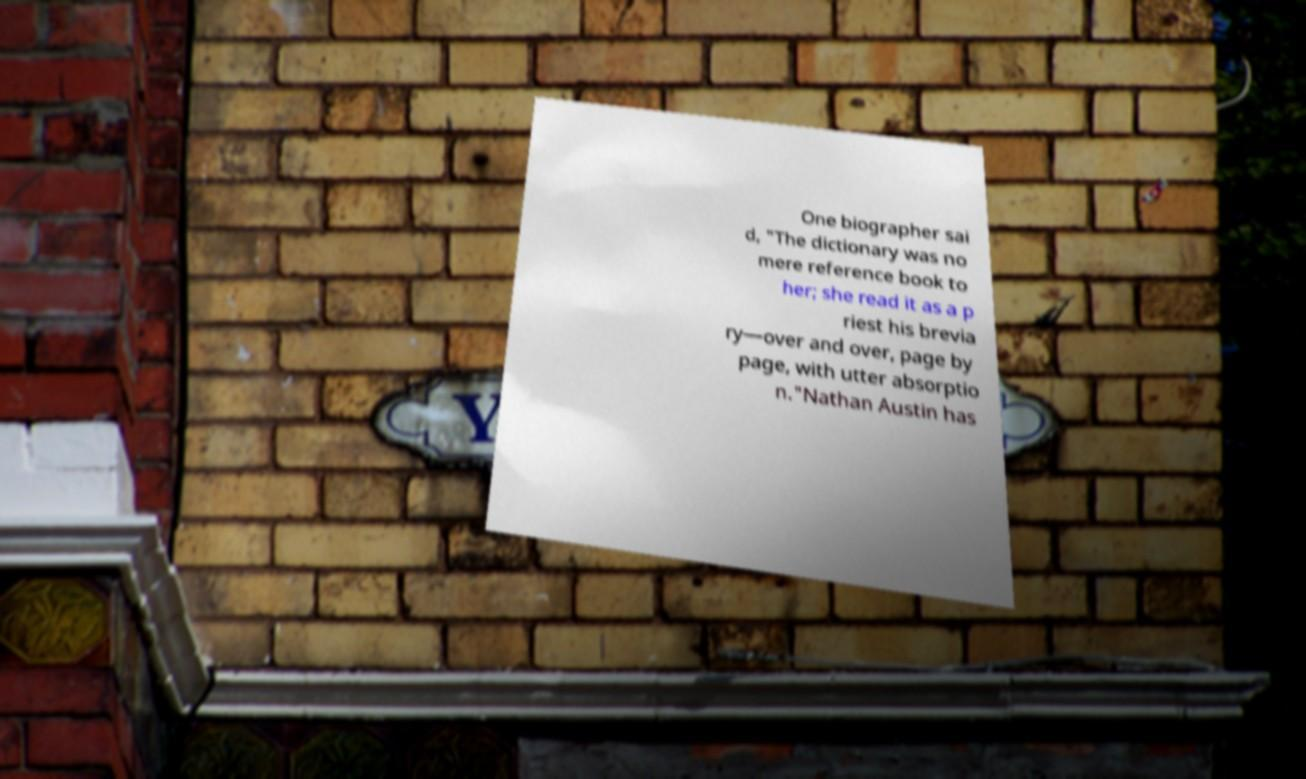There's text embedded in this image that I need extracted. Can you transcribe it verbatim? One biographer sai d, "The dictionary was no mere reference book to her; she read it as a p riest his brevia ry—over and over, page by page, with utter absorptio n."Nathan Austin has 